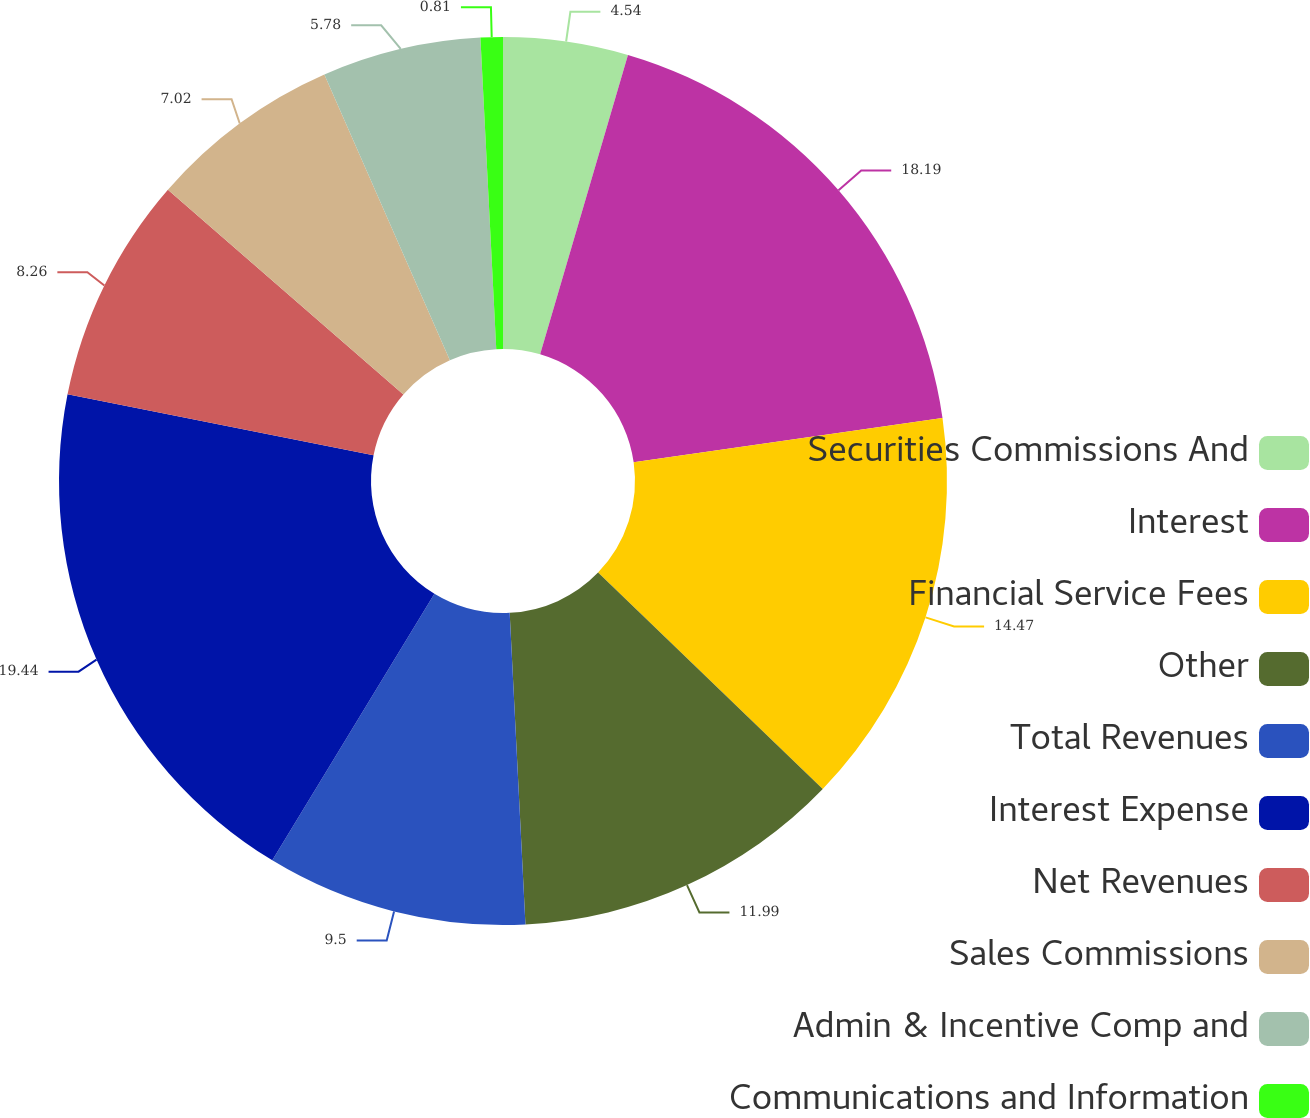<chart> <loc_0><loc_0><loc_500><loc_500><pie_chart><fcel>Securities Commissions And<fcel>Interest<fcel>Financial Service Fees<fcel>Other<fcel>Total Revenues<fcel>Interest Expense<fcel>Net Revenues<fcel>Sales Commissions<fcel>Admin & Incentive Comp and<fcel>Communications and Information<nl><fcel>4.54%<fcel>18.19%<fcel>14.47%<fcel>11.99%<fcel>9.5%<fcel>19.43%<fcel>8.26%<fcel>7.02%<fcel>5.78%<fcel>0.81%<nl></chart> 